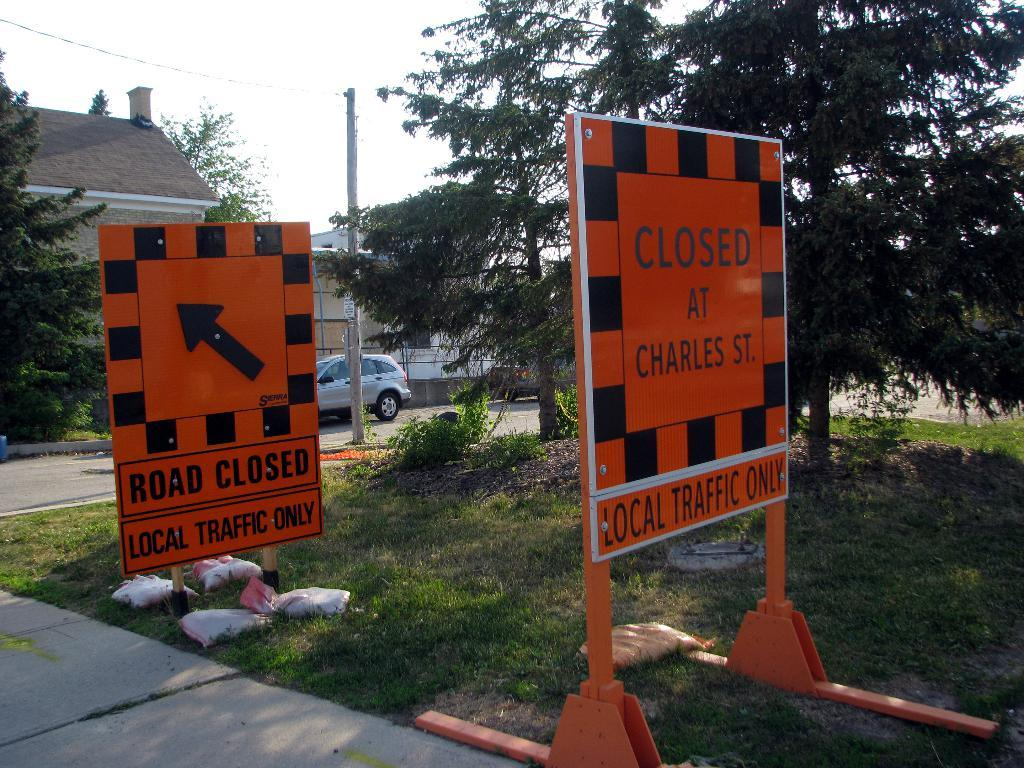What is the main object in the image? There is a name sign board in the image. Where is the sign board located? The sign board is on the surface of the grass. What can be seen behind the sign board? There are trees and buildings behind the sign board. Is there any vehicle visible in the image? Yes, there is a car parked on the road in the image. What type of reward can be seen hanging from the trees in the image? There is no reward hanging from the trees in the image; only trees and buildings are visible behind the sign board. 